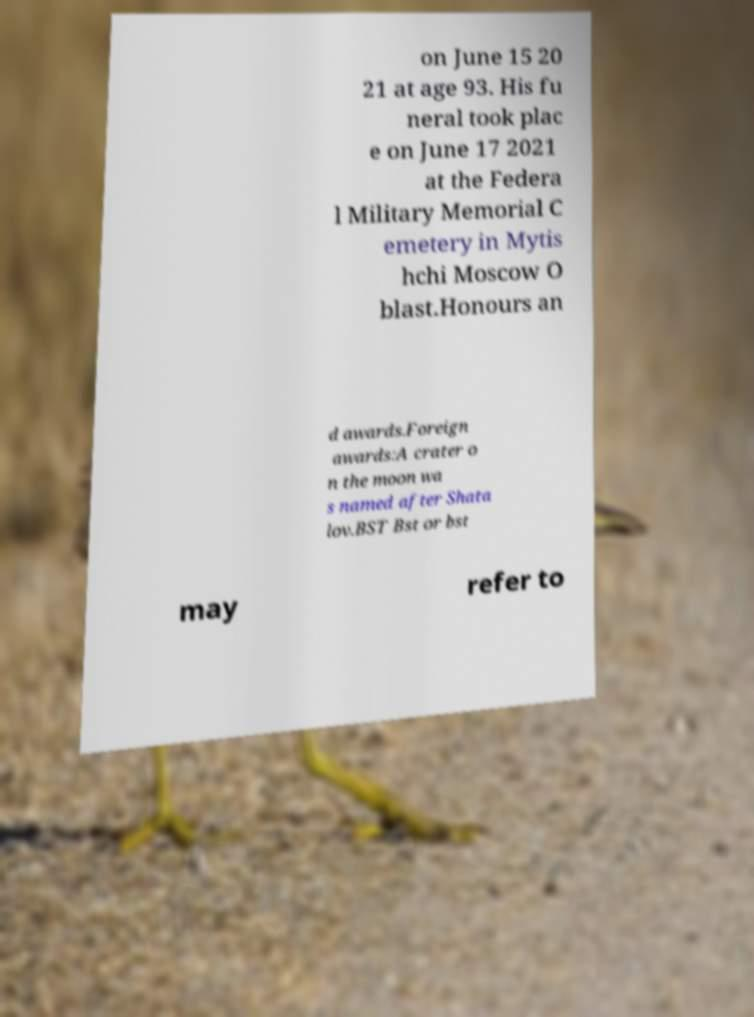What messages or text are displayed in this image? I need them in a readable, typed format. on June 15 20 21 at age 93. His fu neral took plac e on June 17 2021 at the Federa l Military Memorial C emetery in Mytis hchi Moscow O blast.Honours an d awards.Foreign awards:A crater o n the moon wa s named after Shata lov.BST Bst or bst may refer to 